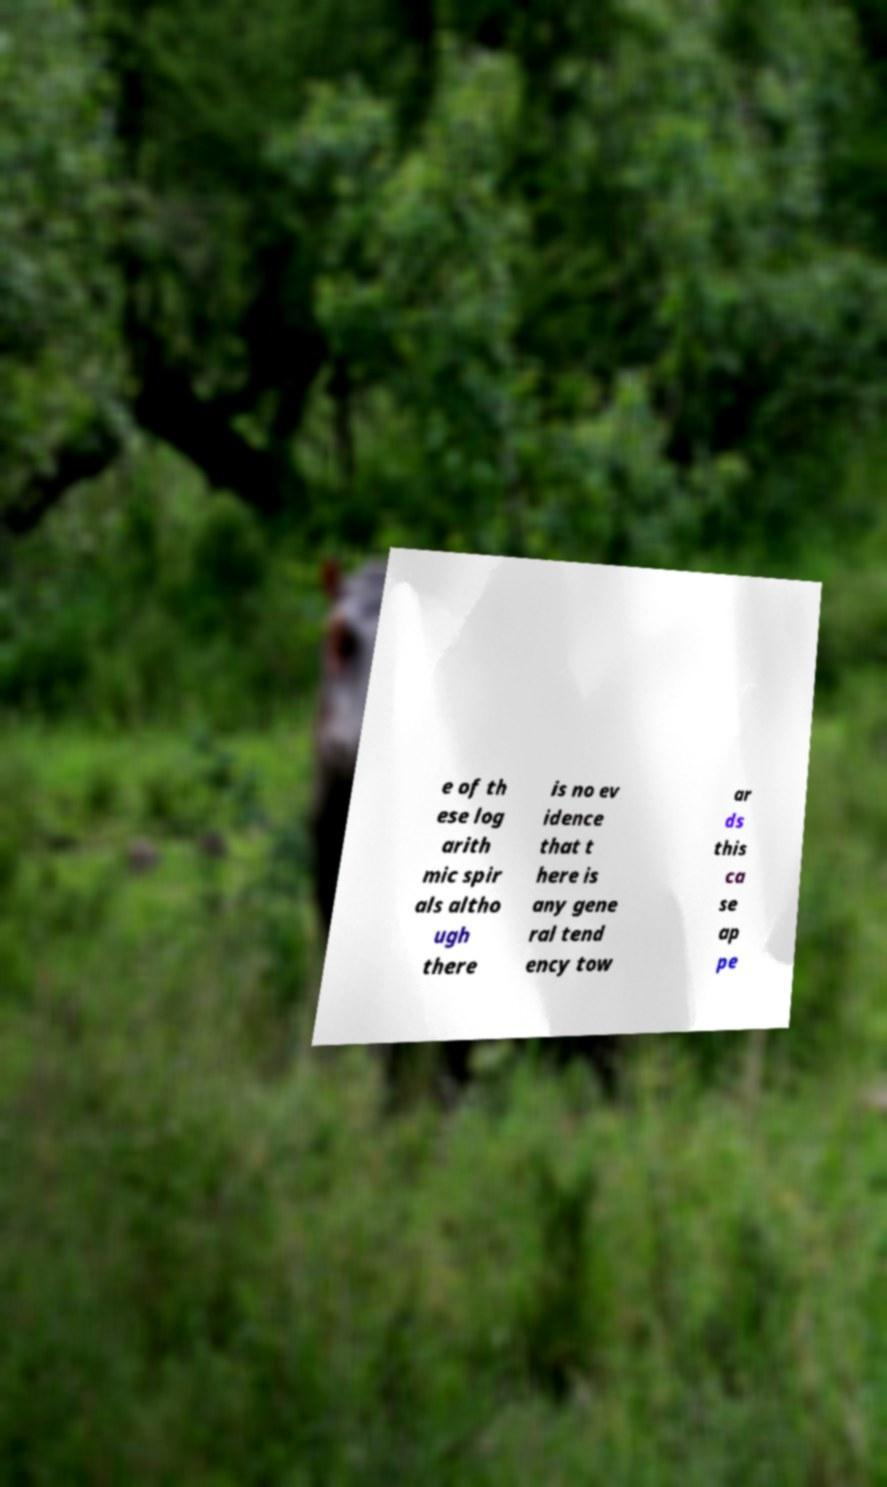Can you read and provide the text displayed in the image?This photo seems to have some interesting text. Can you extract and type it out for me? e of th ese log arith mic spir als altho ugh there is no ev idence that t here is any gene ral tend ency tow ar ds this ca se ap pe 